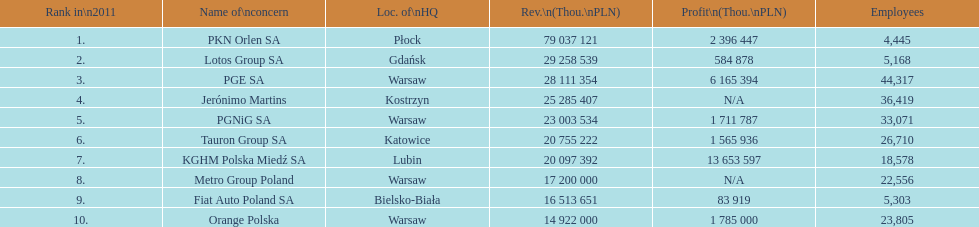What company is the only one with a revenue greater than 75,000,000 thou. pln? PKN Orlen SA. 